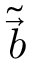<formula> <loc_0><loc_0><loc_500><loc_500>\widetilde { \vec { b } }</formula> 